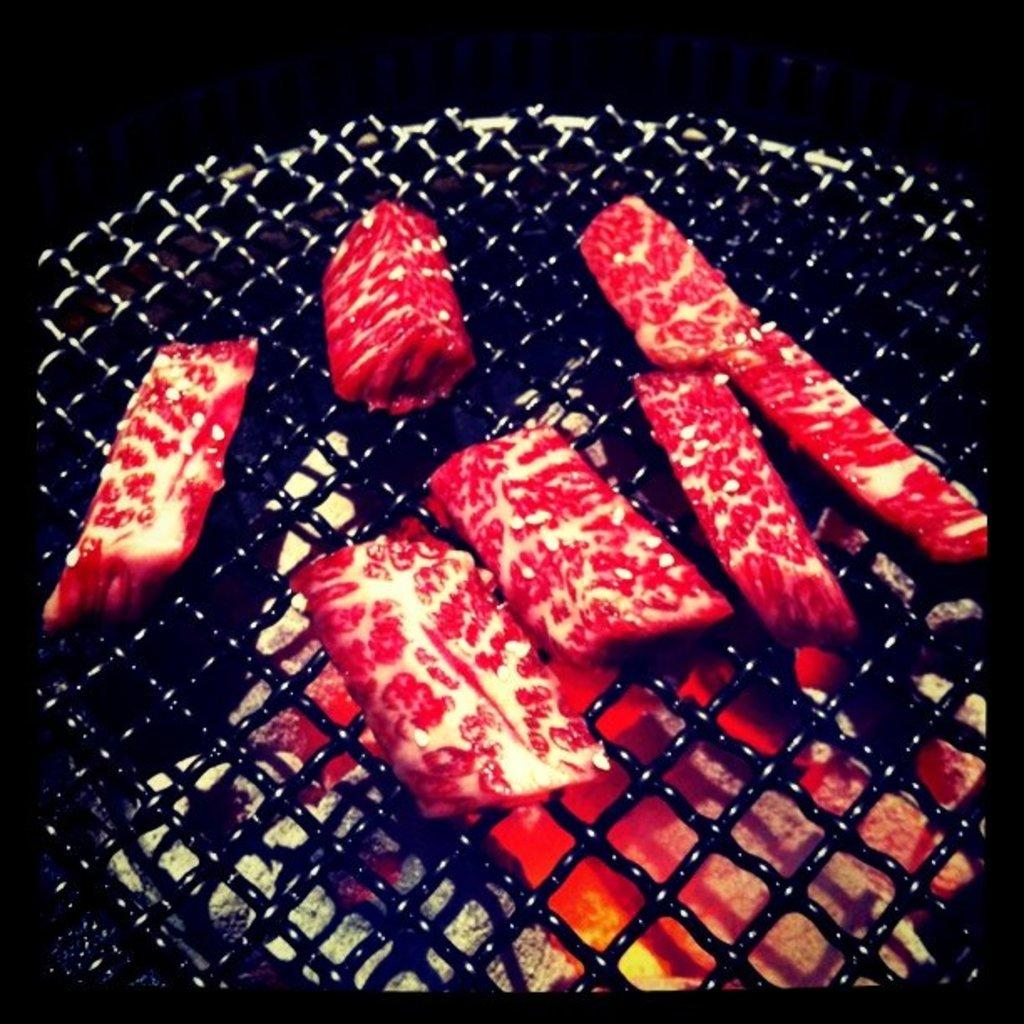What type of food is visible in the image? There are raw pieces of meat in the image. How are the raw pieces of meat being prepared? The raw pieces of meat are placed on a grill. What type of leather is being used to make songs in the image? There is no leather or songs present in the image; it only features raw pieces of meat placed on a grill. 